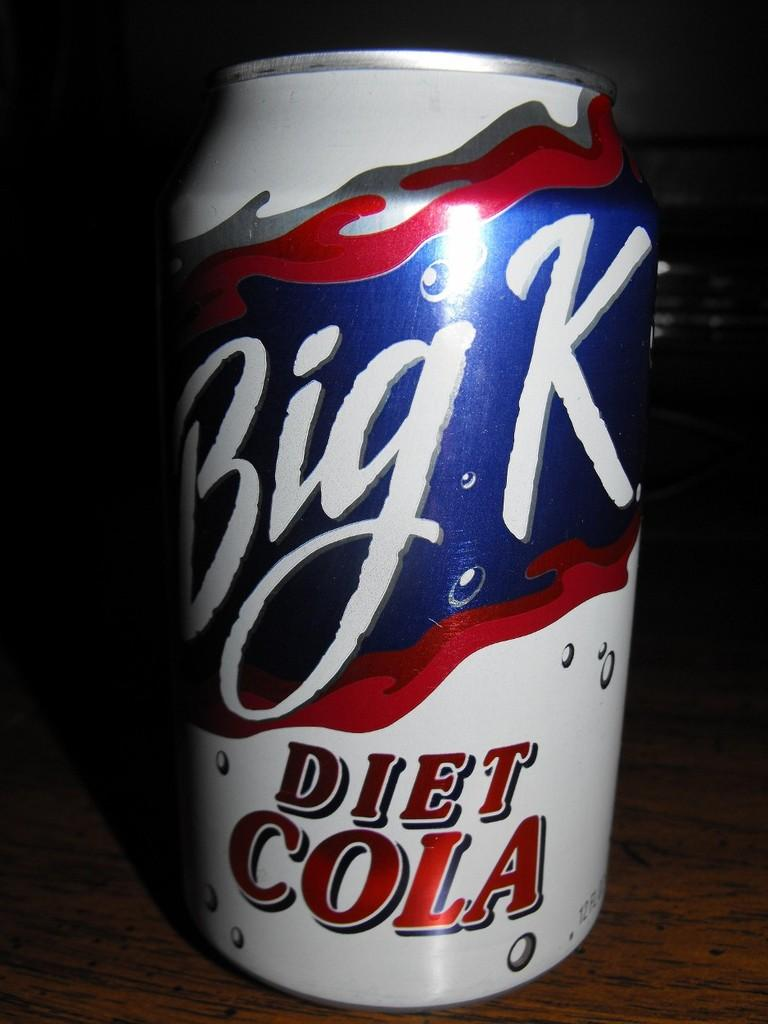<image>
Present a compact description of the photo's key features. a close up of a Big K Diet Cola on a table 